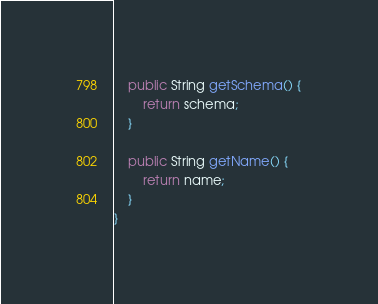<code> <loc_0><loc_0><loc_500><loc_500><_Java_>    public String getSchema() {
        return schema;
    }

    public String getName() {
        return name;
    }
}
</code> 